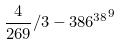<formula> <loc_0><loc_0><loc_500><loc_500>\frac { 4 } { 2 6 9 } / 3 - { 3 8 6 ^ { 3 8 } } ^ { 9 }</formula> 